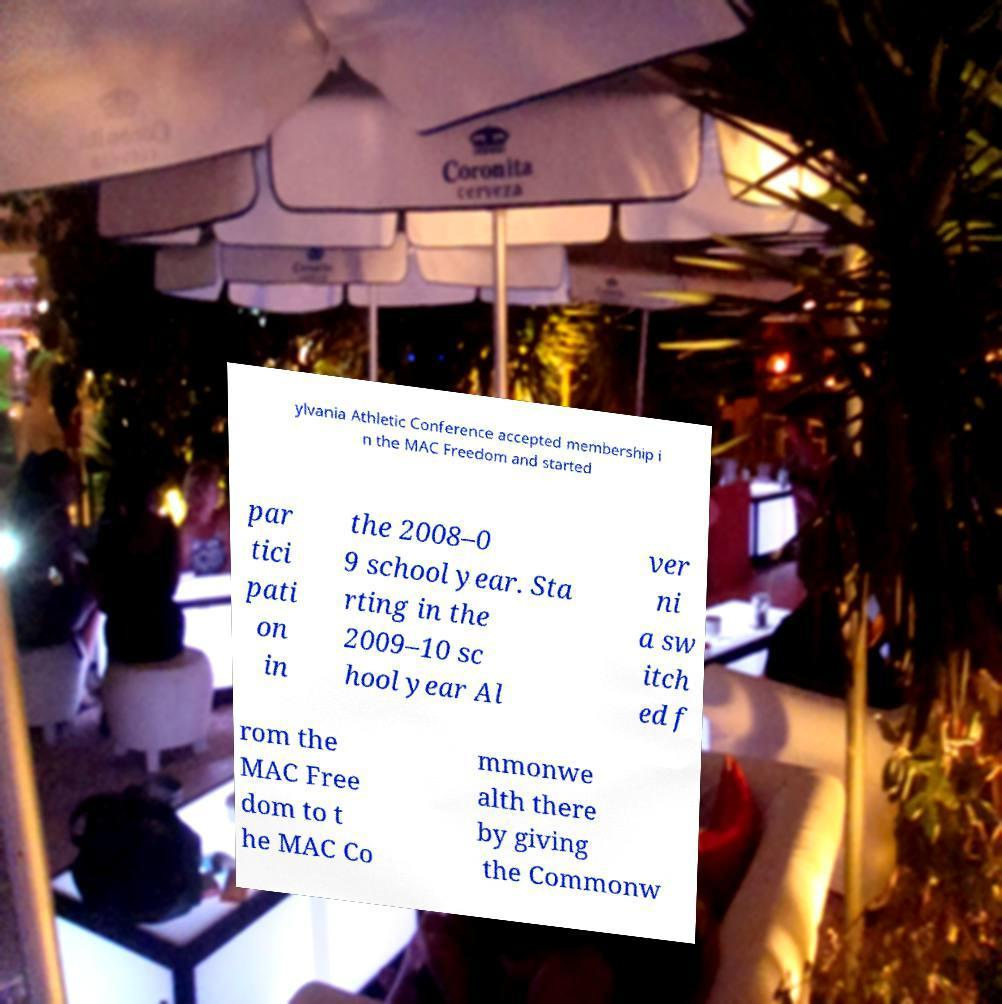For documentation purposes, I need the text within this image transcribed. Could you provide that? ylvania Athletic Conference accepted membership i n the MAC Freedom and started par tici pati on in the 2008–0 9 school year. Sta rting in the 2009–10 sc hool year Al ver ni a sw itch ed f rom the MAC Free dom to t he MAC Co mmonwe alth there by giving the Commonw 